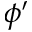<formula> <loc_0><loc_0><loc_500><loc_500>\phi ^ { \prime }</formula> 